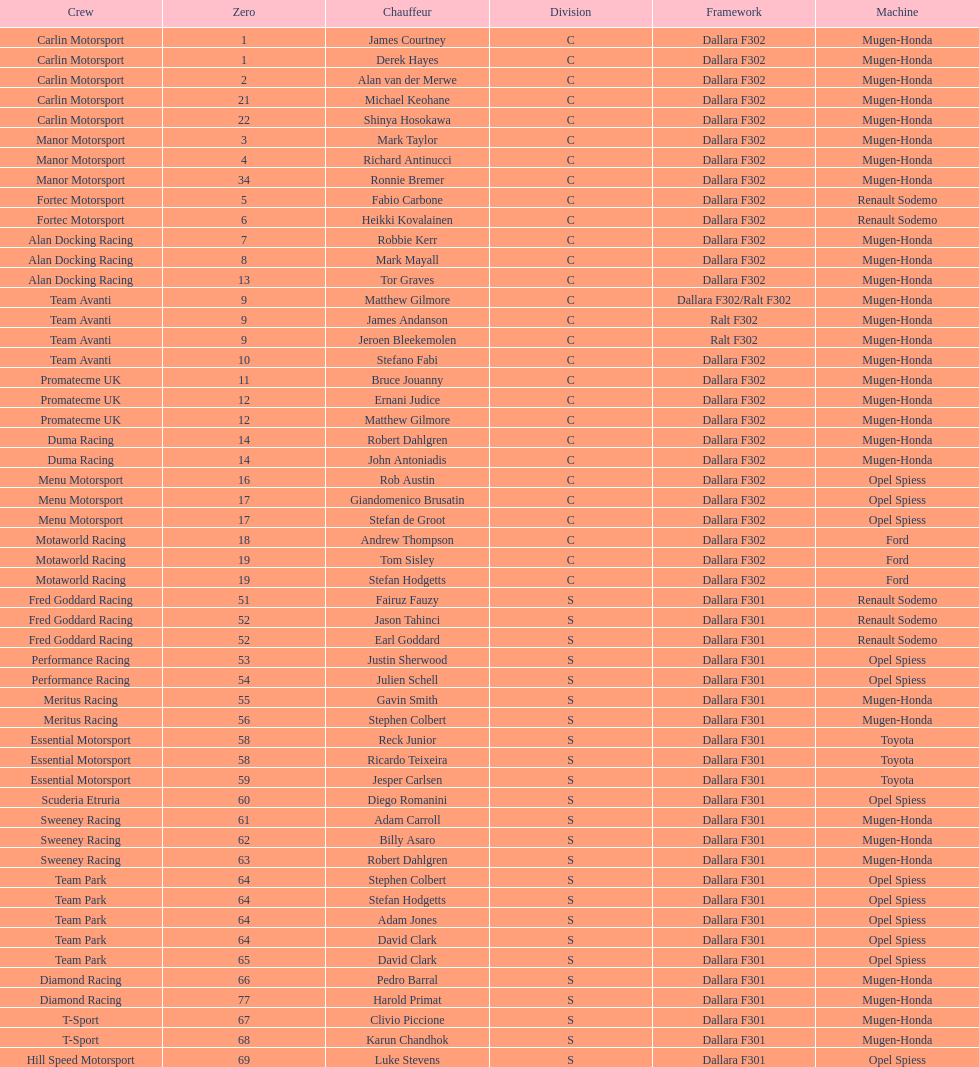Which engine was used the most by teams this season? Mugen-Honda. 